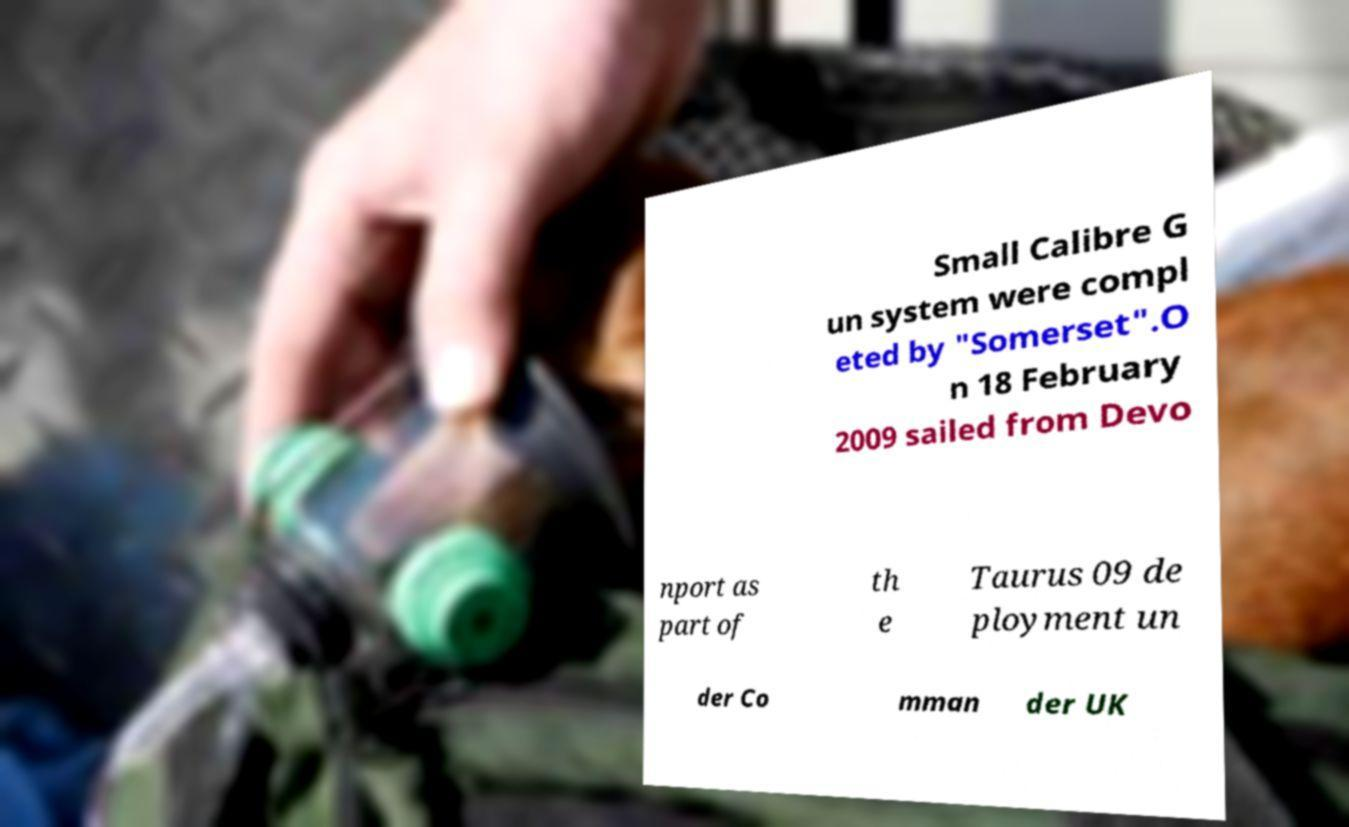There's text embedded in this image that I need extracted. Can you transcribe it verbatim? Small Calibre G un system were compl eted by "Somerset".O n 18 February 2009 sailed from Devo nport as part of th e Taurus 09 de ployment un der Co mman der UK 